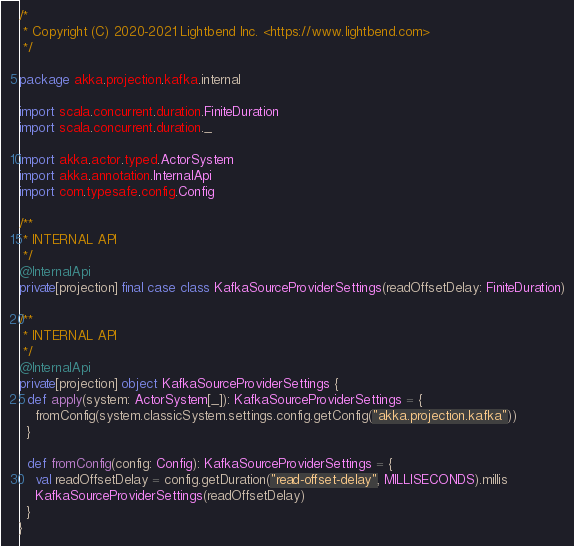Convert code to text. <code><loc_0><loc_0><loc_500><loc_500><_Scala_>/*
 * Copyright (C) 2020-2021 Lightbend Inc. <https://www.lightbend.com>
 */

package akka.projection.kafka.internal

import scala.concurrent.duration.FiniteDuration
import scala.concurrent.duration._

import akka.actor.typed.ActorSystem
import akka.annotation.InternalApi
import com.typesafe.config.Config

/**
 * INTERNAL API
 */
@InternalApi
private[projection] final case class KafkaSourceProviderSettings(readOffsetDelay: FiniteDuration)

/**
 * INTERNAL API
 */
@InternalApi
private[projection] object KafkaSourceProviderSettings {
  def apply(system: ActorSystem[_]): KafkaSourceProviderSettings = {
    fromConfig(system.classicSystem.settings.config.getConfig("akka.projection.kafka"))
  }

  def fromConfig(config: Config): KafkaSourceProviderSettings = {
    val readOffsetDelay = config.getDuration("read-offset-delay", MILLISECONDS).millis
    KafkaSourceProviderSettings(readOffsetDelay)
  }
}
</code> 